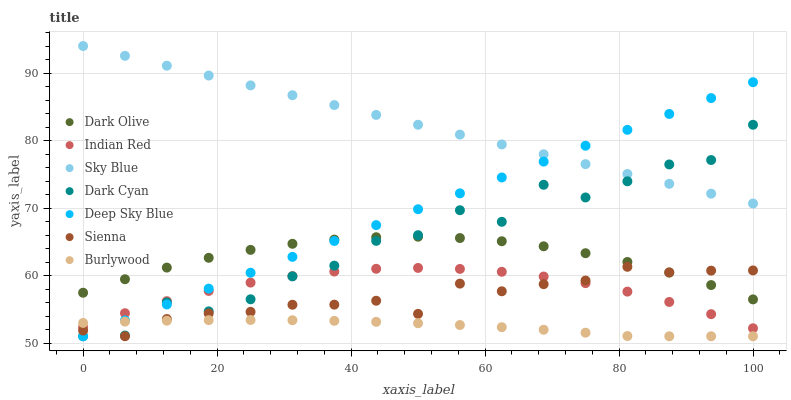Does Burlywood have the minimum area under the curve?
Answer yes or no. Yes. Does Sky Blue have the maximum area under the curve?
Answer yes or no. Yes. Does Dark Olive have the minimum area under the curve?
Answer yes or no. No. Does Dark Olive have the maximum area under the curve?
Answer yes or no. No. Is Deep Sky Blue the smoothest?
Answer yes or no. Yes. Is Dark Cyan the roughest?
Answer yes or no. Yes. Is Burlywood the smoothest?
Answer yes or no. No. Is Burlywood the roughest?
Answer yes or no. No. Does Burlywood have the lowest value?
Answer yes or no. Yes. Does Dark Olive have the lowest value?
Answer yes or no. No. Does Sky Blue have the highest value?
Answer yes or no. Yes. Does Dark Olive have the highest value?
Answer yes or no. No. Is Indian Red less than Dark Olive?
Answer yes or no. Yes. Is Dark Olive greater than Indian Red?
Answer yes or no. Yes. Does Sienna intersect Dark Cyan?
Answer yes or no. Yes. Is Sienna less than Dark Cyan?
Answer yes or no. No. Is Sienna greater than Dark Cyan?
Answer yes or no. No. Does Indian Red intersect Dark Olive?
Answer yes or no. No. 